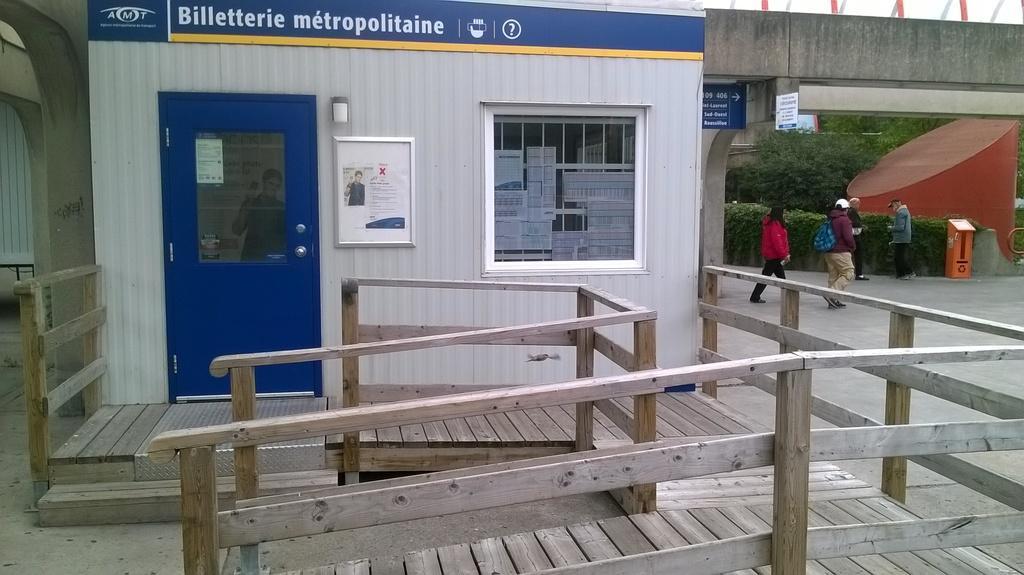How would you summarize this image in a sentence or two? In this image we can see a building with a blue door and we can see a photo frame attached to the wall and at the top there is a board with text. We can see some people on the road and there are some trees and plants and there is a bridge with sign board with text on it. 